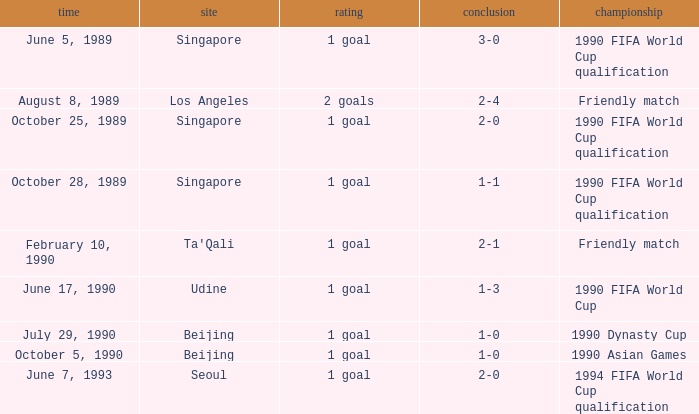What was the venue where the result was 2-1? Ta'Qali. 